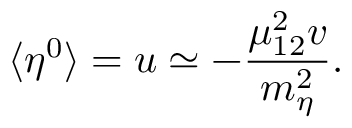<formula> <loc_0><loc_0><loc_500><loc_500>\langle \eta ^ { 0 } \rangle = u \simeq - { \frac { \mu _ { 1 2 } ^ { 2 } v } { m _ { \eta } ^ { 2 } } } .</formula> 